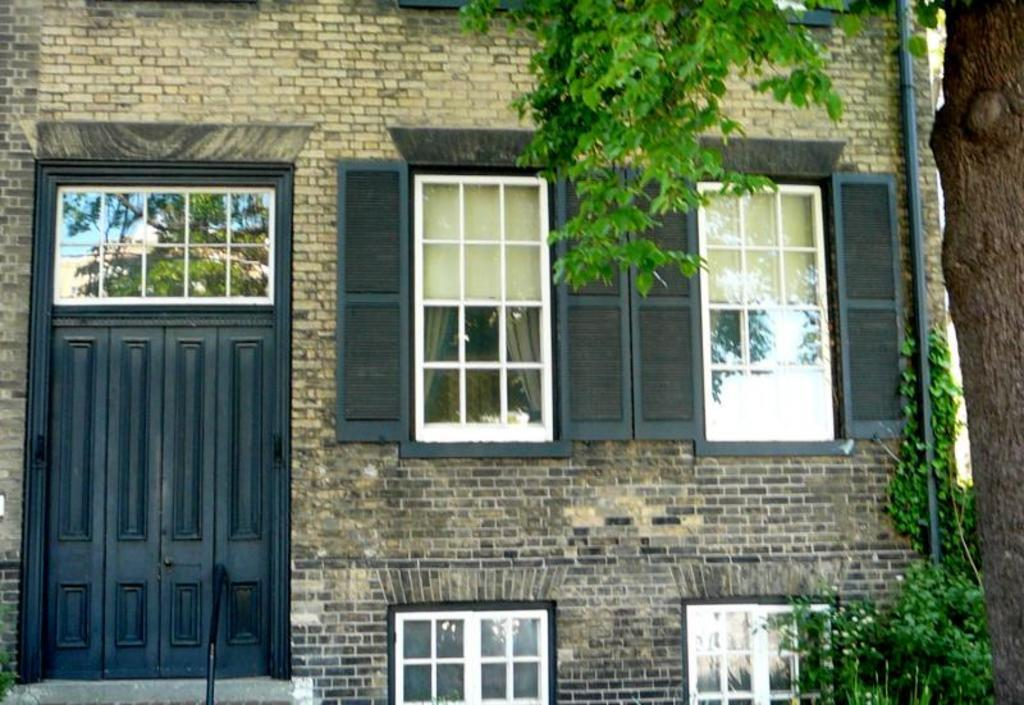What type of structure is visible in the image? There is a building in the image. What is a feature of the building that allows access? There is a door in the image. What is a feature of the building that allows light and air to enter? There is a window in the image. What type of vegetation is present in the image? There are plants and a tree in the image. Reasoning: Let'ing: Let's think step by step in order to produce the conversation. We start by identifying the main subject in the image, which is the building. Then, we expand the conversation to include other features of the building, such as the door and window. Finally, we mention the vegetation present in the image, including plants and a tree. Each question is designed to elicit a specific detail about the image that is known from the provided facts. Absurd Question/Answer: Where is the stove located in the image? There is no stove present in the image. Can you see a tiger walking in the image? There is no tiger present in the image. What direction is the front of the building facing in the image? The provided facts do not specify the direction the building is facing, so we cannot definitively answer this question. 